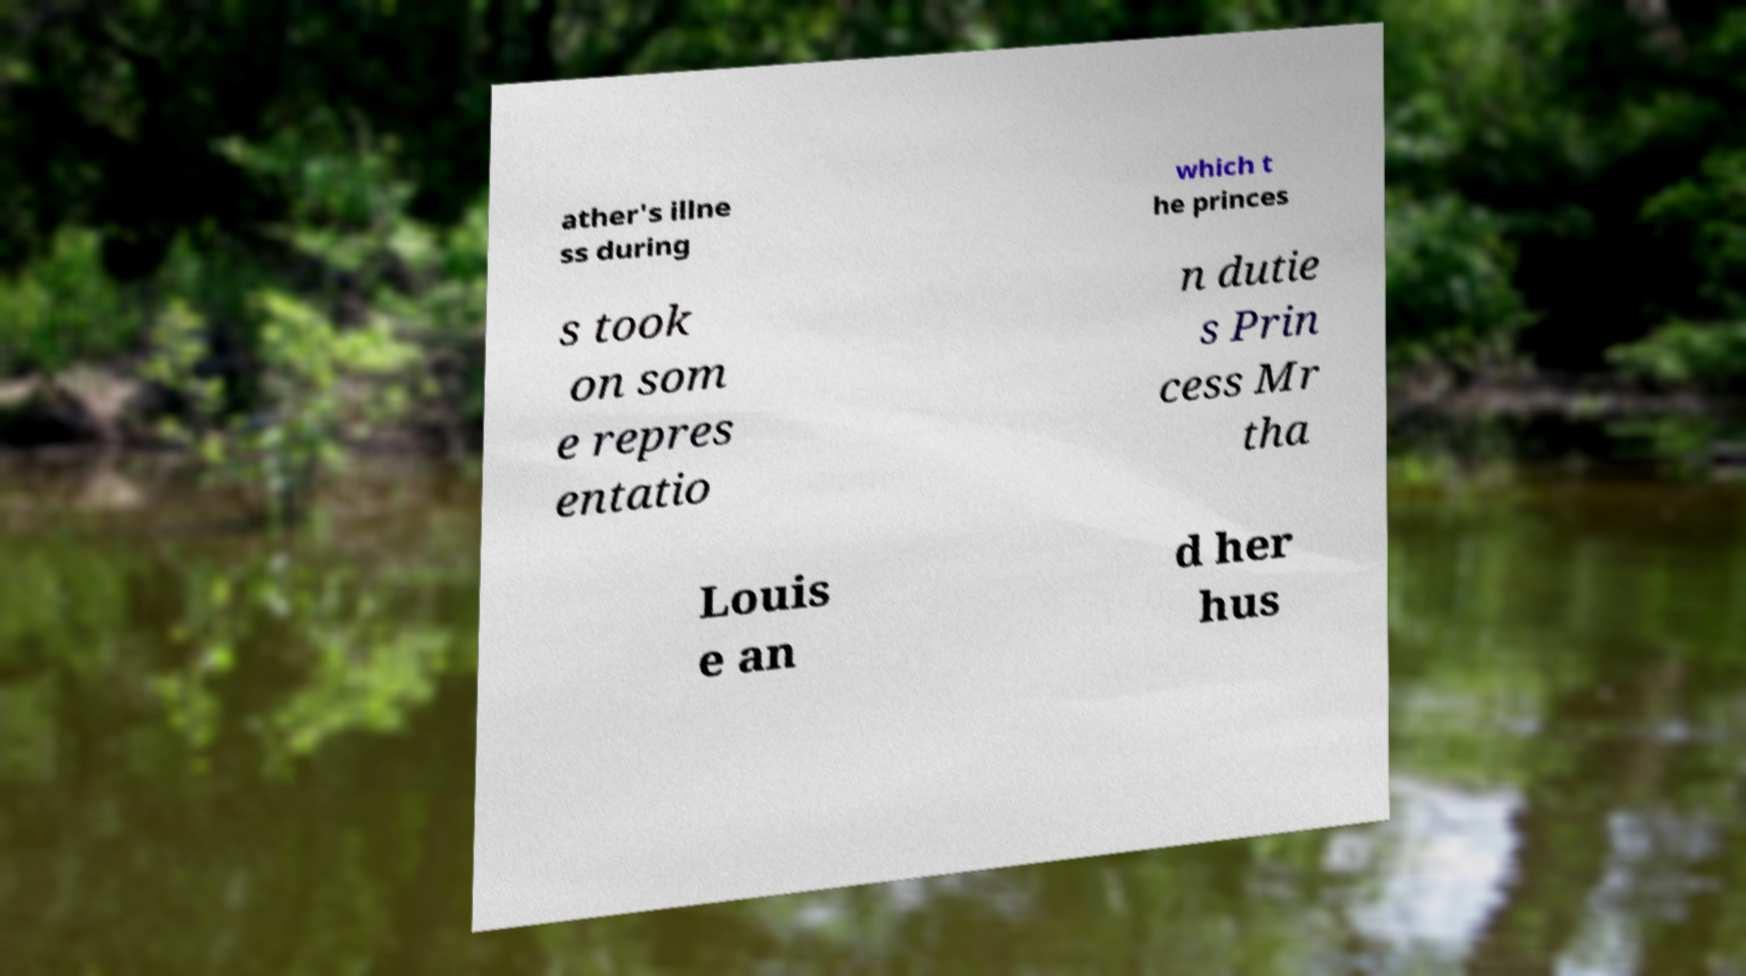Could you extract and type out the text from this image? ather's illne ss during which t he princes s took on som e repres entatio n dutie s Prin cess Mr tha Louis e an d her hus 